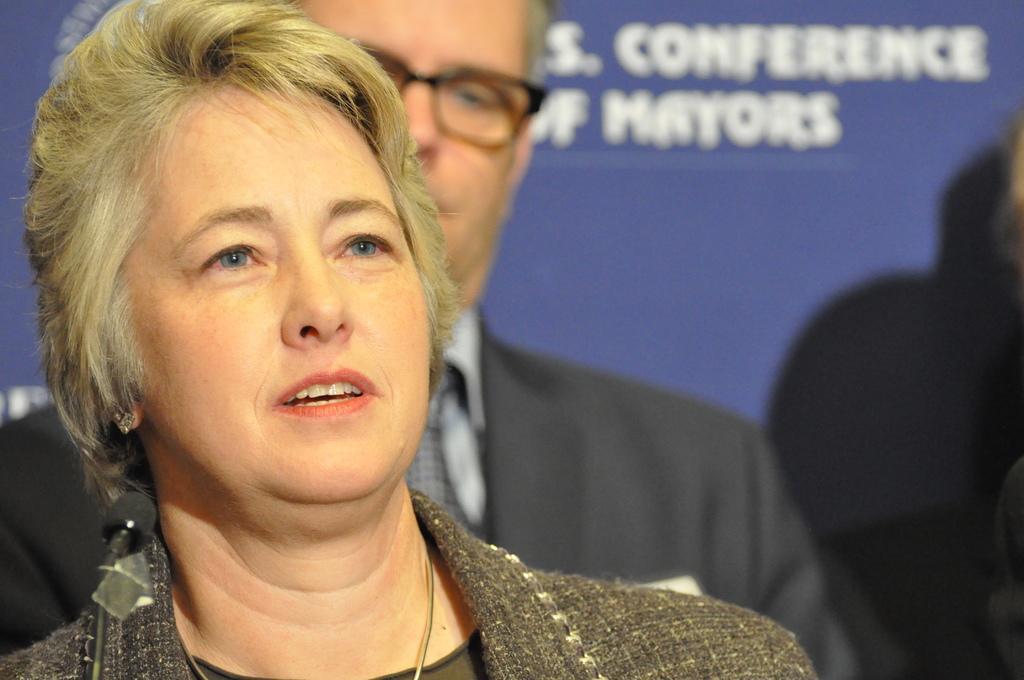In one or two sentences, can you explain what this image depicts? In the picture there is a woman and a man standing, behind there is a banner with the text. 